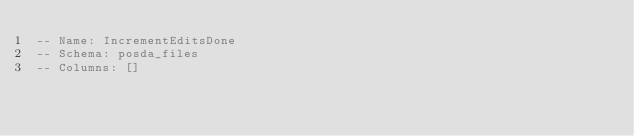Convert code to text. <code><loc_0><loc_0><loc_500><loc_500><_SQL_>-- Name: IncrementEditsDone
-- Schema: posda_files
-- Columns: []</code> 